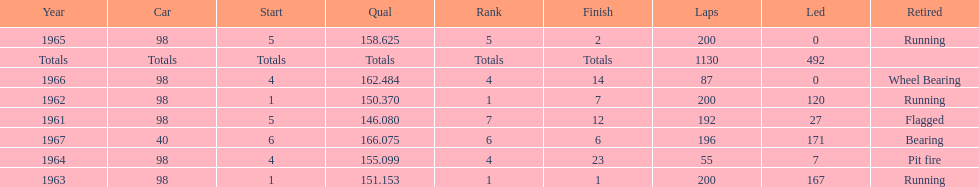Previous to 1965, when did jones have a number 5 start at the indy 500? 1961. 